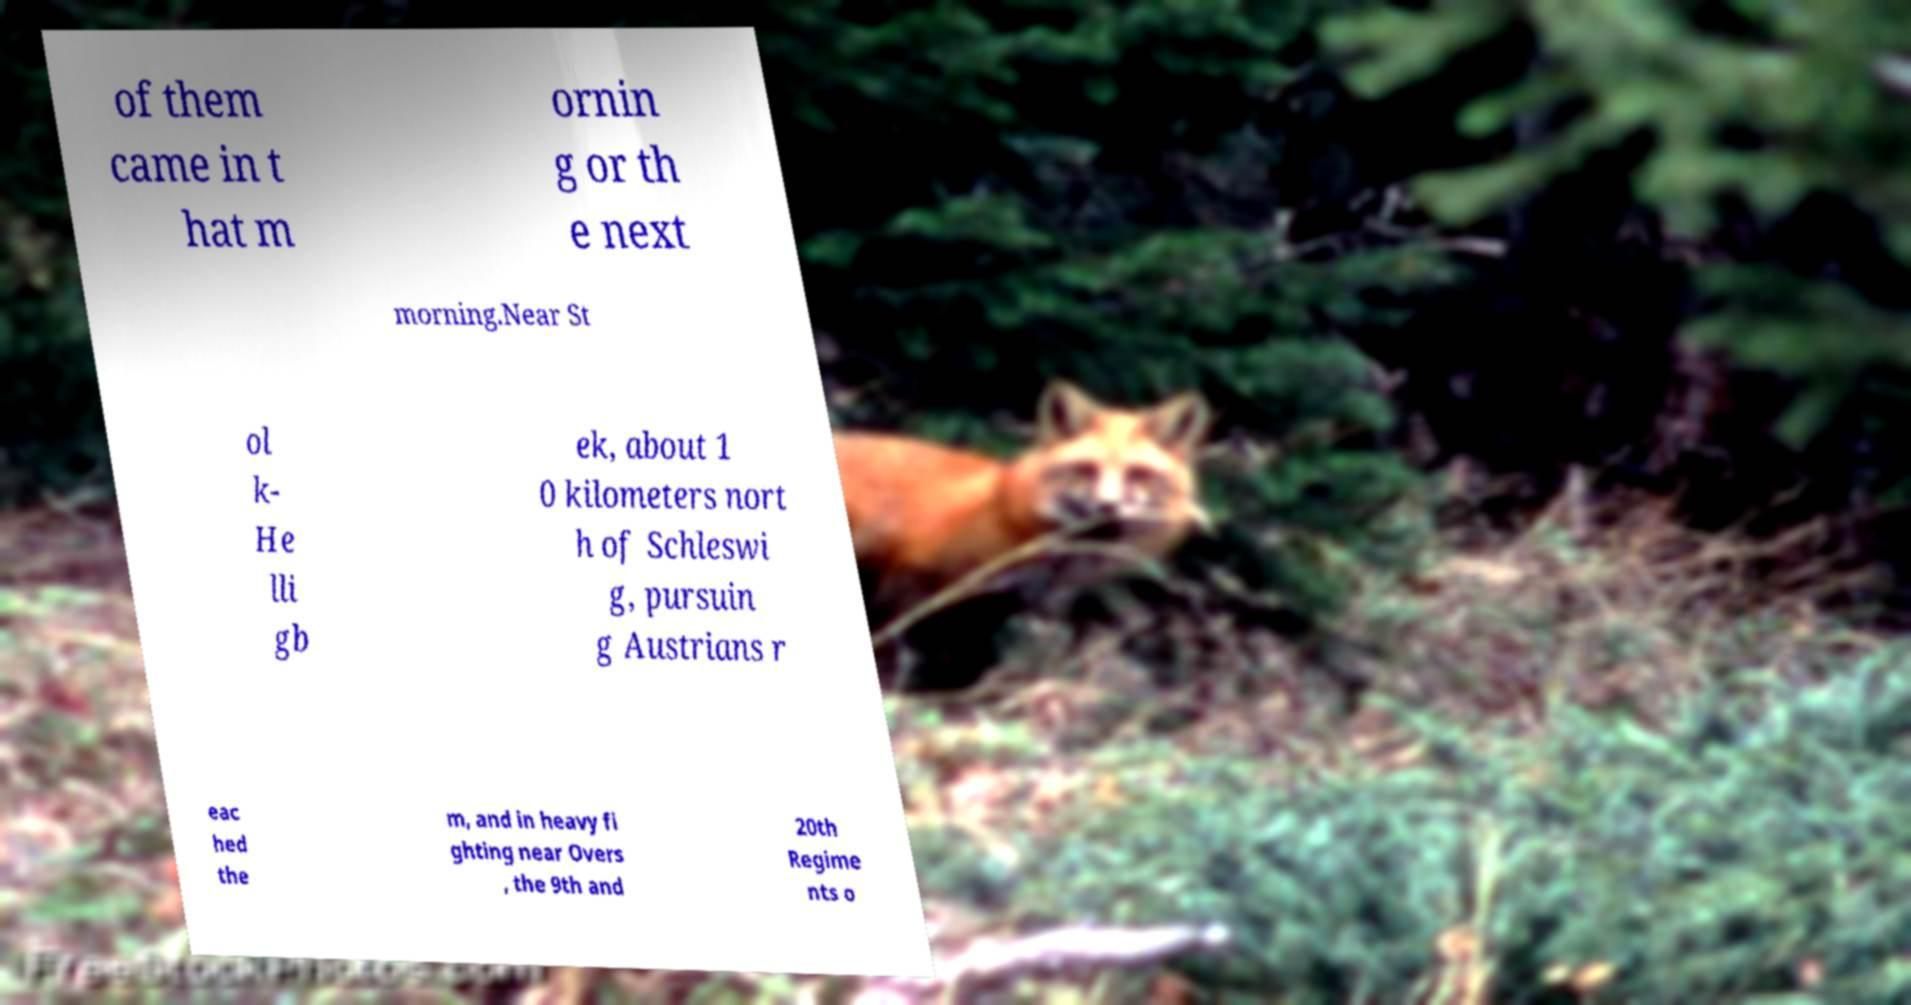Please identify and transcribe the text found in this image. of them came in t hat m ornin g or th e next morning.Near St ol k- He lli gb ek, about 1 0 kilometers nort h of Schleswi g, pursuin g Austrians r eac hed the m, and in heavy fi ghting near Overs , the 9th and 20th Regime nts o 